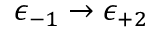Convert formula to latex. <formula><loc_0><loc_0><loc_500><loc_500>\epsilon _ { - 1 } \to \epsilon _ { + 2 }</formula> 